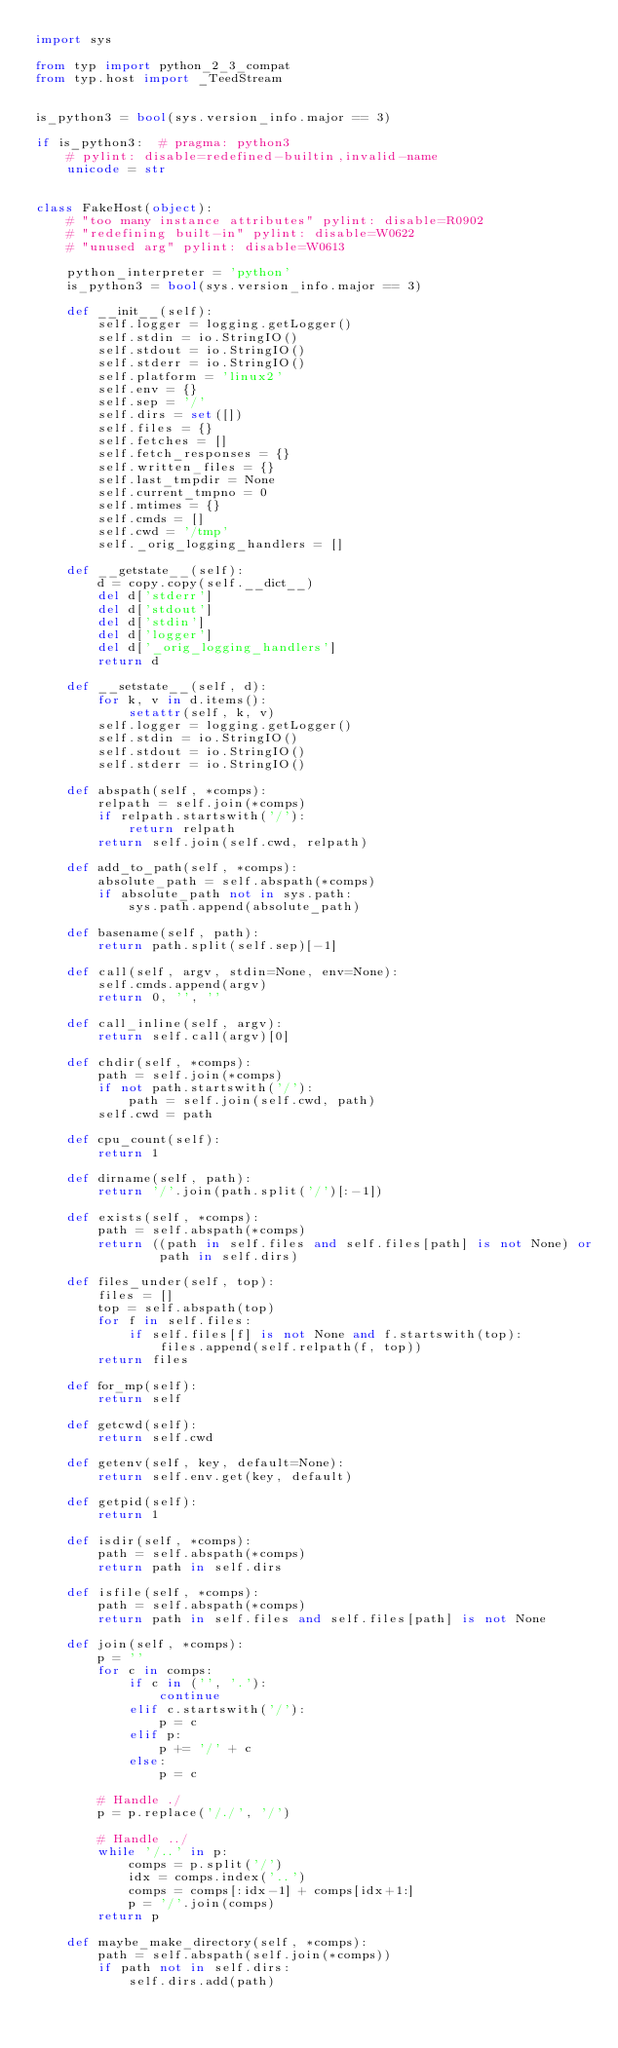<code> <loc_0><loc_0><loc_500><loc_500><_Python_>import sys

from typ import python_2_3_compat
from typ.host import _TeedStream


is_python3 = bool(sys.version_info.major == 3)

if is_python3:  # pragma: python3
    # pylint: disable=redefined-builtin,invalid-name
    unicode = str


class FakeHost(object):
    # "too many instance attributes" pylint: disable=R0902
    # "redefining built-in" pylint: disable=W0622
    # "unused arg" pylint: disable=W0613

    python_interpreter = 'python'
    is_python3 = bool(sys.version_info.major == 3)

    def __init__(self):
        self.logger = logging.getLogger()
        self.stdin = io.StringIO()
        self.stdout = io.StringIO()
        self.stderr = io.StringIO()
        self.platform = 'linux2'
        self.env = {}
        self.sep = '/'
        self.dirs = set([])
        self.files = {}
        self.fetches = []
        self.fetch_responses = {}
        self.written_files = {}
        self.last_tmpdir = None
        self.current_tmpno = 0
        self.mtimes = {}
        self.cmds = []
        self.cwd = '/tmp'
        self._orig_logging_handlers = []

    def __getstate__(self):
        d = copy.copy(self.__dict__)
        del d['stderr']
        del d['stdout']
        del d['stdin']
        del d['logger']
        del d['_orig_logging_handlers']
        return d

    def __setstate__(self, d):
        for k, v in d.items():
            setattr(self, k, v)
        self.logger = logging.getLogger()
        self.stdin = io.StringIO()
        self.stdout = io.StringIO()
        self.stderr = io.StringIO()

    def abspath(self, *comps):
        relpath = self.join(*comps)
        if relpath.startswith('/'):
            return relpath
        return self.join(self.cwd, relpath)

    def add_to_path(self, *comps):
        absolute_path = self.abspath(*comps)
        if absolute_path not in sys.path:
            sys.path.append(absolute_path)

    def basename(self, path):
        return path.split(self.sep)[-1]

    def call(self, argv, stdin=None, env=None):
        self.cmds.append(argv)
        return 0, '', ''

    def call_inline(self, argv):
        return self.call(argv)[0]

    def chdir(self, *comps):
        path = self.join(*comps)
        if not path.startswith('/'):
            path = self.join(self.cwd, path)
        self.cwd = path

    def cpu_count(self):
        return 1

    def dirname(self, path):
        return '/'.join(path.split('/')[:-1])

    def exists(self, *comps):
        path = self.abspath(*comps)
        return ((path in self.files and self.files[path] is not None) or
                path in self.dirs)

    def files_under(self, top):
        files = []
        top = self.abspath(top)
        for f in self.files:
            if self.files[f] is not None and f.startswith(top):
                files.append(self.relpath(f, top))
        return files

    def for_mp(self):
        return self

    def getcwd(self):
        return self.cwd

    def getenv(self, key, default=None):
        return self.env.get(key, default)

    def getpid(self):
        return 1

    def isdir(self, *comps):
        path = self.abspath(*comps)
        return path in self.dirs

    def isfile(self, *comps):
        path = self.abspath(*comps)
        return path in self.files and self.files[path] is not None

    def join(self, *comps):
        p = ''
        for c in comps:
            if c in ('', '.'):
                continue
            elif c.startswith('/'):
                p = c
            elif p:
                p += '/' + c
            else:
                p = c

        # Handle ./
        p = p.replace('/./', '/')

        # Handle ../
        while '/..' in p:
            comps = p.split('/')
            idx = comps.index('..')
            comps = comps[:idx-1] + comps[idx+1:]
            p = '/'.join(comps)
        return p

    def maybe_make_directory(self, *comps):
        path = self.abspath(self.join(*comps))
        if path not in self.dirs:
            self.dirs.add(path)
</code> 